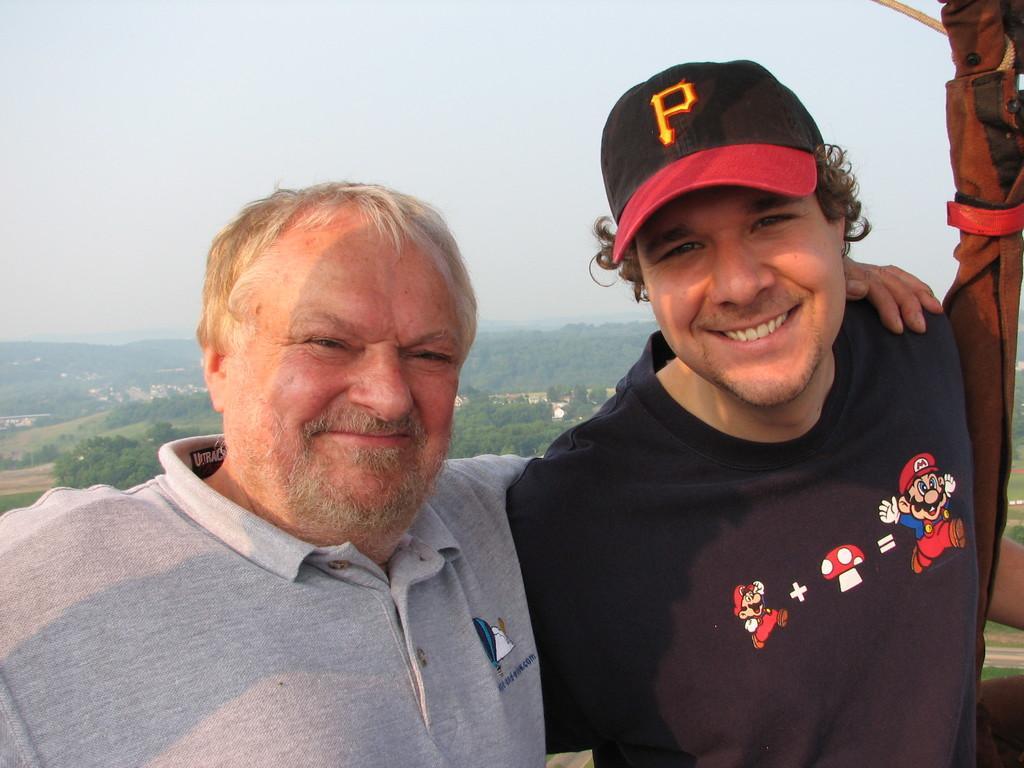How would you summarize this image in a sentence or two? In this image, we can see two men. On the right side, we can also see a cloth. In the background, we can see some trees, houses, plants, mountains. At the top, we can see a sky. 